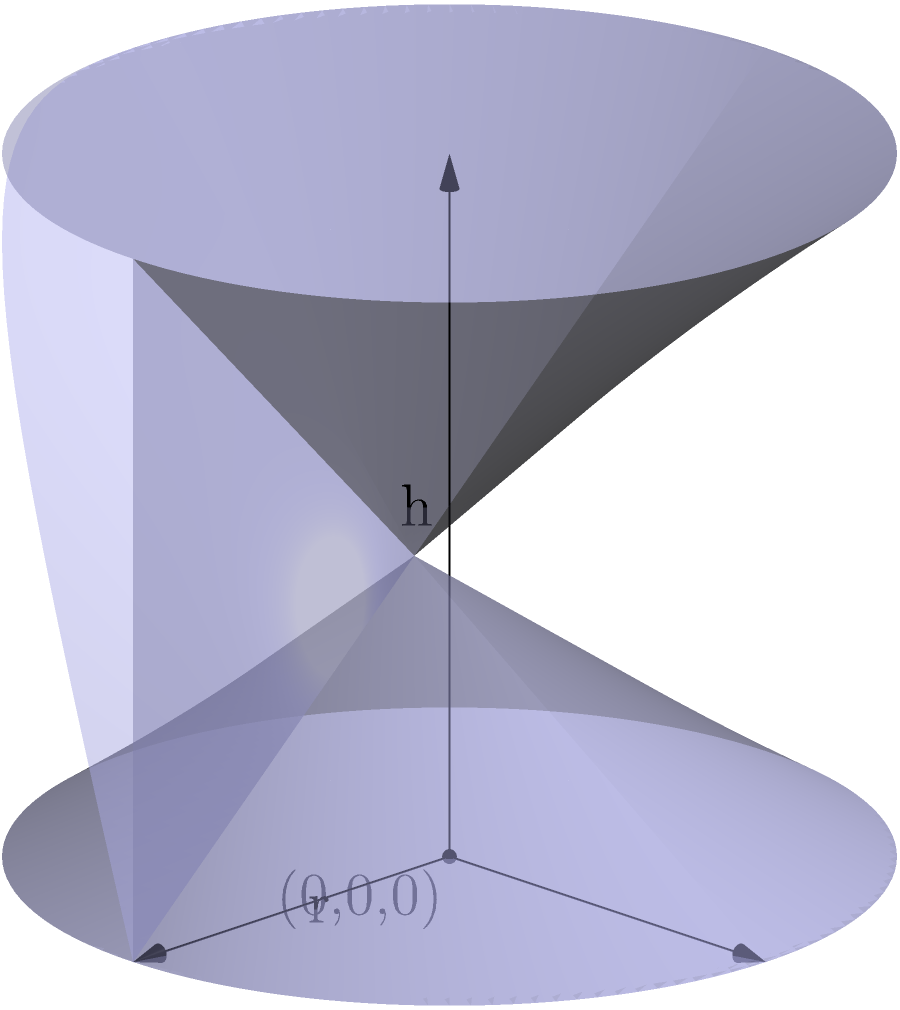As a home baker inspired by Prachi Dhabal Deb's exquisite cake designs, you want to calculate the volume of a cylindrical cake tin. If the tin has a diameter of 15 cm and a height of 10 cm, what is its volume in cubic centimeters (cm³)? Round your answer to the nearest whole number. To calculate the volume of a cylindrical cake tin, we need to use the formula for the volume of a cylinder:

$$V = \pi r^2 h$$

Where:
$V$ = volume
$\pi$ = pi (approximately 3.14159)
$r$ = radius of the base
$h$ = height of the cylinder

Given:
- Diameter = 15 cm
- Height = 10 cm

Step 1: Calculate the radius
The radius is half the diameter:
$$r = \frac{15}{2} = 7.5 \text{ cm}$$

Step 2: Apply the volume formula
$$V = \pi (7.5 \text{ cm})^2 (10 \text{ cm})$$

Step 3: Calculate
$$V = 3.14159 \times 56.25 \text{ cm}^2 \times 10 \text{ cm}$$
$$V = 1767.15 \text{ cm}^3$$

Step 4: Round to the nearest whole number
$$V \approx 1767 \text{ cm}^3$$
Answer: 1767 cm³ 